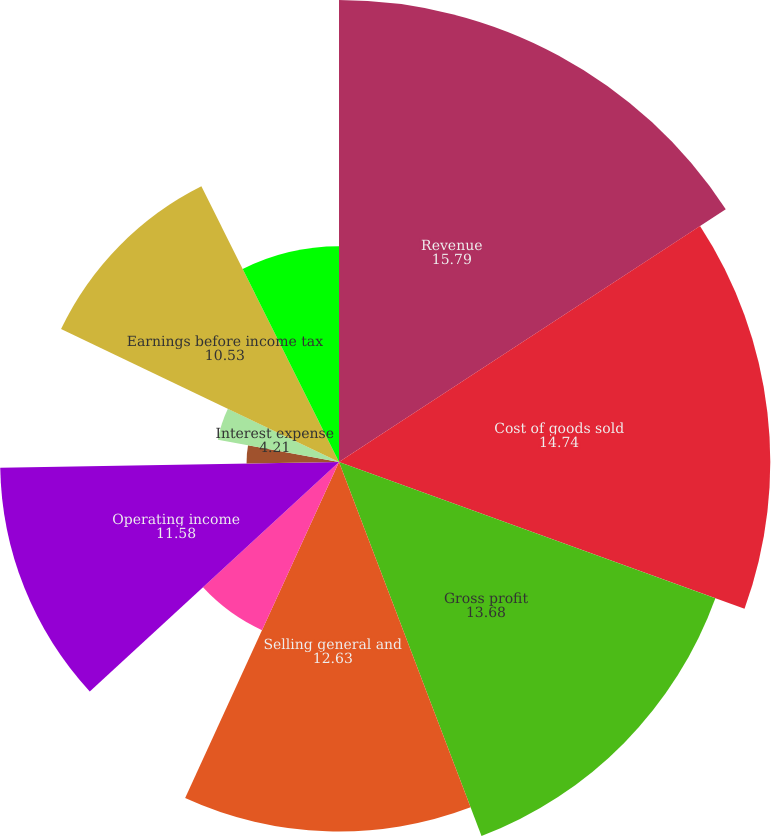<chart> <loc_0><loc_0><loc_500><loc_500><pie_chart><fcel>Revenue<fcel>Cost of goods sold<fcel>Gross profit<fcel>Selling general and<fcel>Restructuring charges<fcel>Operating income<fcel>Investment income and other<fcel>Interest expense<fcel>Earnings before income tax<fcel>Income tax expense<nl><fcel>15.79%<fcel>14.74%<fcel>13.68%<fcel>12.63%<fcel>6.32%<fcel>11.58%<fcel>3.16%<fcel>4.21%<fcel>10.53%<fcel>7.37%<nl></chart> 